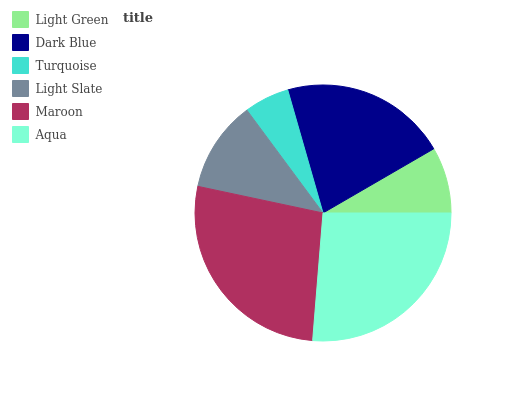Is Turquoise the minimum?
Answer yes or no. Yes. Is Maroon the maximum?
Answer yes or no. Yes. Is Dark Blue the minimum?
Answer yes or no. No. Is Dark Blue the maximum?
Answer yes or no. No. Is Dark Blue greater than Light Green?
Answer yes or no. Yes. Is Light Green less than Dark Blue?
Answer yes or no. Yes. Is Light Green greater than Dark Blue?
Answer yes or no. No. Is Dark Blue less than Light Green?
Answer yes or no. No. Is Dark Blue the high median?
Answer yes or no. Yes. Is Light Slate the low median?
Answer yes or no. Yes. Is Light Slate the high median?
Answer yes or no. No. Is Aqua the low median?
Answer yes or no. No. 